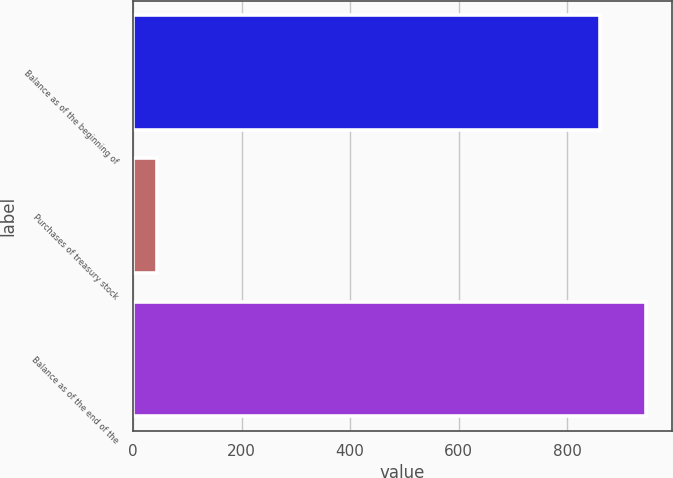Convert chart. <chart><loc_0><loc_0><loc_500><loc_500><bar_chart><fcel>Balance as of the beginning of<fcel>Purchases of treasury stock<fcel>Balance as of the end of the<nl><fcel>860<fcel>45<fcel>946<nl></chart> 